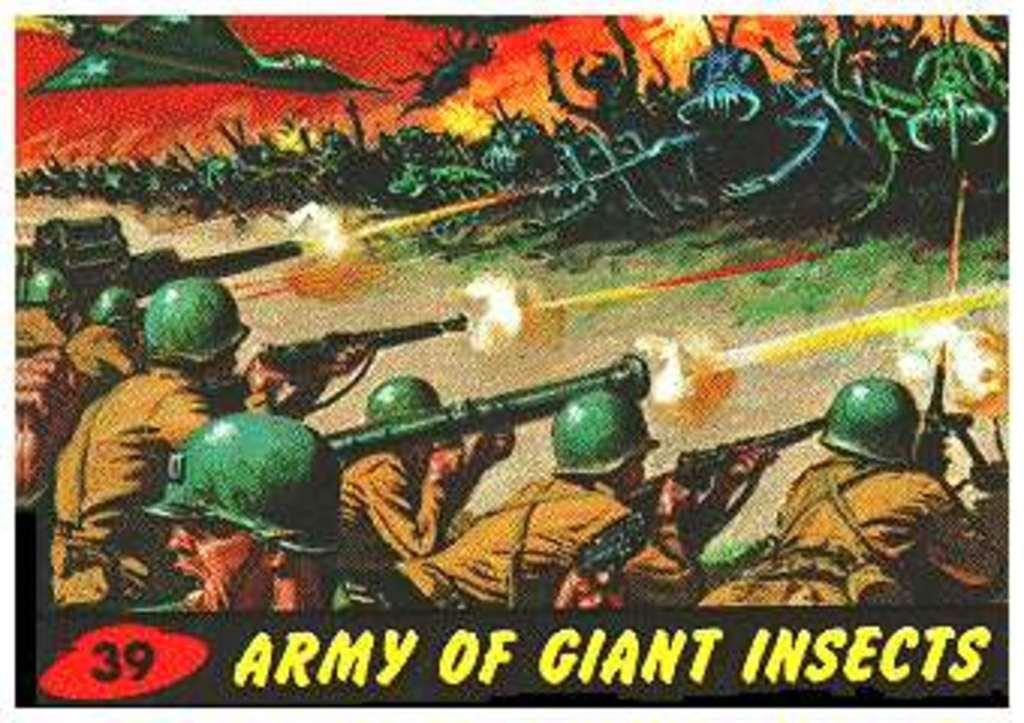How would you summarize this image in a sentence or two? In this picture we can see a poster, in this poster there are people holding guns and we can see text. 